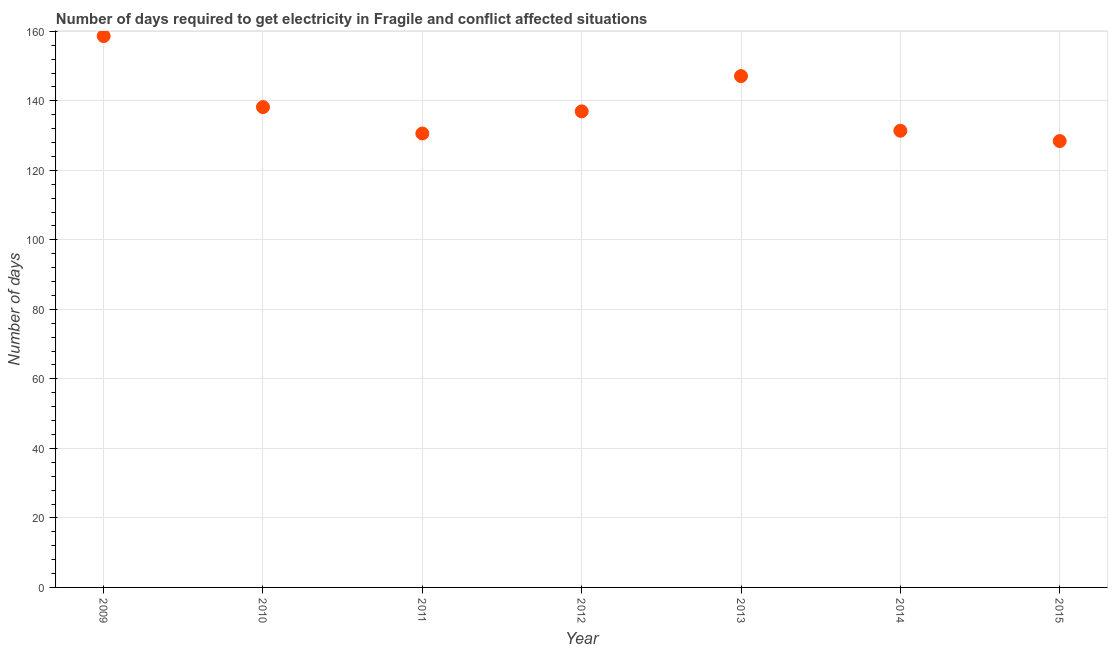What is the time to get electricity in 2009?
Offer a terse response. 158.63. Across all years, what is the maximum time to get electricity?
Offer a very short reply. 158.63. Across all years, what is the minimum time to get electricity?
Make the answer very short. 128.42. In which year was the time to get electricity minimum?
Give a very brief answer. 2015. What is the sum of the time to get electricity?
Provide a short and direct response. 971.34. What is the difference between the time to get electricity in 2011 and 2014?
Offer a very short reply. -0.79. What is the average time to get electricity per year?
Your answer should be very brief. 138.76. What is the median time to get electricity?
Ensure brevity in your answer.  136.97. What is the ratio of the time to get electricity in 2010 to that in 2011?
Offer a very short reply. 1.06. Is the time to get electricity in 2010 less than that in 2011?
Provide a short and direct response. No. What is the difference between the highest and the second highest time to get electricity?
Keep it short and to the point. 11.51. What is the difference between the highest and the lowest time to get electricity?
Your answer should be very brief. 30.21. Does the time to get electricity monotonically increase over the years?
Offer a terse response. No. What is the title of the graph?
Your answer should be very brief. Number of days required to get electricity in Fragile and conflict affected situations. What is the label or title of the X-axis?
Your response must be concise. Year. What is the label or title of the Y-axis?
Offer a very short reply. Number of days. What is the Number of days in 2009?
Your answer should be very brief. 158.63. What is the Number of days in 2010?
Give a very brief answer. 138.2. What is the Number of days in 2011?
Ensure brevity in your answer.  130.6. What is the Number of days in 2012?
Provide a short and direct response. 136.97. What is the Number of days in 2013?
Provide a succinct answer. 147.12. What is the Number of days in 2014?
Give a very brief answer. 131.39. What is the Number of days in 2015?
Offer a very short reply. 128.42. What is the difference between the Number of days in 2009 and 2010?
Offer a terse response. 20.43. What is the difference between the Number of days in 2009 and 2011?
Offer a very short reply. 28.03. What is the difference between the Number of days in 2009 and 2012?
Offer a very short reply. 21.66. What is the difference between the Number of days in 2009 and 2013?
Your answer should be compact. 11.51. What is the difference between the Number of days in 2009 and 2014?
Provide a short and direct response. 27.24. What is the difference between the Number of days in 2009 and 2015?
Keep it short and to the point. 30.21. What is the difference between the Number of days in 2010 and 2011?
Provide a succinct answer. 7.6. What is the difference between the Number of days in 2010 and 2012?
Make the answer very short. 1.23. What is the difference between the Number of days in 2010 and 2013?
Keep it short and to the point. -8.92. What is the difference between the Number of days in 2010 and 2014?
Provide a short and direct response. 6.81. What is the difference between the Number of days in 2010 and 2015?
Your response must be concise. 9.78. What is the difference between the Number of days in 2011 and 2012?
Give a very brief answer. -6.37. What is the difference between the Number of days in 2011 and 2013?
Keep it short and to the point. -16.52. What is the difference between the Number of days in 2011 and 2014?
Ensure brevity in your answer.  -0.79. What is the difference between the Number of days in 2011 and 2015?
Ensure brevity in your answer.  2.18. What is the difference between the Number of days in 2012 and 2013?
Provide a succinct answer. -10.15. What is the difference between the Number of days in 2012 and 2014?
Your answer should be compact. 5.58. What is the difference between the Number of days in 2012 and 2015?
Provide a short and direct response. 8.55. What is the difference between the Number of days in 2013 and 2014?
Give a very brief answer. 15.73. What is the difference between the Number of days in 2013 and 2015?
Your answer should be very brief. 18.7. What is the difference between the Number of days in 2014 and 2015?
Your response must be concise. 2.97. What is the ratio of the Number of days in 2009 to that in 2010?
Your response must be concise. 1.15. What is the ratio of the Number of days in 2009 to that in 2011?
Your answer should be compact. 1.22. What is the ratio of the Number of days in 2009 to that in 2012?
Offer a very short reply. 1.16. What is the ratio of the Number of days in 2009 to that in 2013?
Provide a succinct answer. 1.08. What is the ratio of the Number of days in 2009 to that in 2014?
Keep it short and to the point. 1.21. What is the ratio of the Number of days in 2009 to that in 2015?
Provide a succinct answer. 1.24. What is the ratio of the Number of days in 2010 to that in 2011?
Ensure brevity in your answer.  1.06. What is the ratio of the Number of days in 2010 to that in 2012?
Provide a succinct answer. 1.01. What is the ratio of the Number of days in 2010 to that in 2013?
Your answer should be very brief. 0.94. What is the ratio of the Number of days in 2010 to that in 2014?
Provide a short and direct response. 1.05. What is the ratio of the Number of days in 2010 to that in 2015?
Provide a short and direct response. 1.08. What is the ratio of the Number of days in 2011 to that in 2012?
Provide a succinct answer. 0.95. What is the ratio of the Number of days in 2011 to that in 2013?
Ensure brevity in your answer.  0.89. What is the ratio of the Number of days in 2011 to that in 2015?
Make the answer very short. 1.02. What is the ratio of the Number of days in 2012 to that in 2014?
Your response must be concise. 1.04. What is the ratio of the Number of days in 2012 to that in 2015?
Give a very brief answer. 1.07. What is the ratio of the Number of days in 2013 to that in 2014?
Give a very brief answer. 1.12. What is the ratio of the Number of days in 2013 to that in 2015?
Keep it short and to the point. 1.15. 